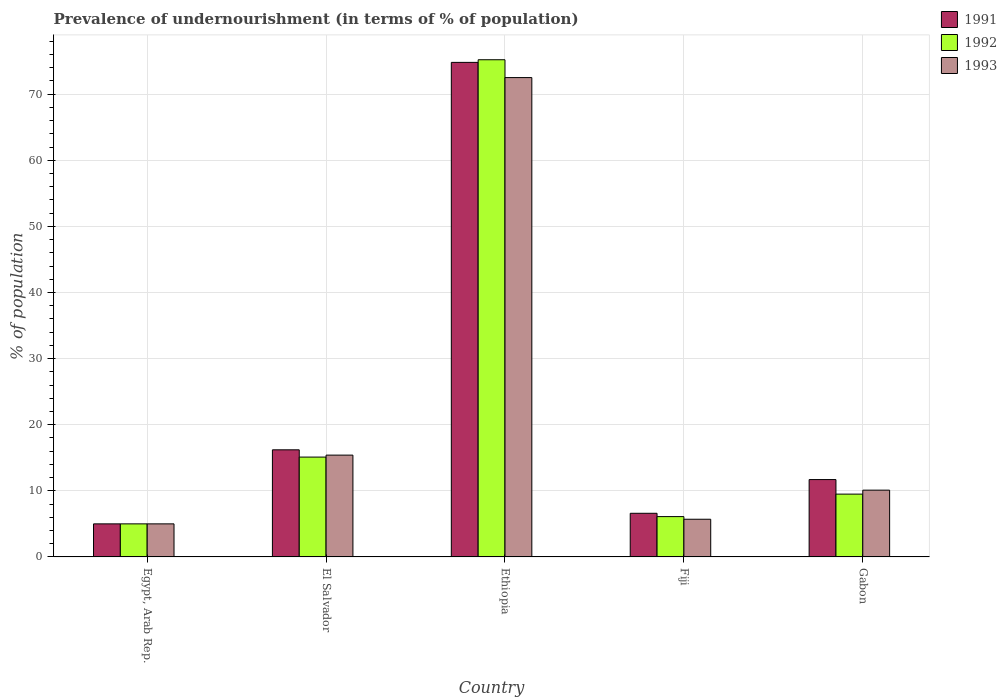How many different coloured bars are there?
Provide a short and direct response. 3. What is the label of the 1st group of bars from the left?
Keep it short and to the point. Egypt, Arab Rep. What is the percentage of undernourished population in 1993 in Ethiopia?
Offer a terse response. 72.5. Across all countries, what is the maximum percentage of undernourished population in 1993?
Provide a short and direct response. 72.5. In which country was the percentage of undernourished population in 1992 maximum?
Your answer should be compact. Ethiopia. In which country was the percentage of undernourished population in 1992 minimum?
Your answer should be very brief. Egypt, Arab Rep. What is the total percentage of undernourished population in 1991 in the graph?
Your response must be concise. 114.3. What is the difference between the percentage of undernourished population in 1993 in El Salvador and that in Ethiopia?
Give a very brief answer. -57.1. What is the average percentage of undernourished population in 1992 per country?
Offer a terse response. 22.18. What is the difference between the percentage of undernourished population of/in 1991 and percentage of undernourished population of/in 1993 in Fiji?
Provide a short and direct response. 0.9. In how many countries, is the percentage of undernourished population in 1992 greater than 46 %?
Make the answer very short. 1. What is the ratio of the percentage of undernourished population in 1991 in Fiji to that in Gabon?
Make the answer very short. 0.56. Is the percentage of undernourished population in 1991 in Fiji less than that in Gabon?
Offer a very short reply. Yes. Is the difference between the percentage of undernourished population in 1991 in Egypt, Arab Rep. and El Salvador greater than the difference between the percentage of undernourished population in 1993 in Egypt, Arab Rep. and El Salvador?
Provide a succinct answer. No. What is the difference between the highest and the second highest percentage of undernourished population in 1992?
Your answer should be compact. -65.7. What is the difference between the highest and the lowest percentage of undernourished population in 1992?
Your response must be concise. 70.2. What does the 1st bar from the left in Ethiopia represents?
Give a very brief answer. 1991. What does the 1st bar from the right in Fiji represents?
Offer a very short reply. 1993. Is it the case that in every country, the sum of the percentage of undernourished population in 1993 and percentage of undernourished population in 1992 is greater than the percentage of undernourished population in 1991?
Your answer should be very brief. Yes. How many countries are there in the graph?
Keep it short and to the point. 5. What is the difference between two consecutive major ticks on the Y-axis?
Make the answer very short. 10. Where does the legend appear in the graph?
Offer a terse response. Top right. How many legend labels are there?
Provide a succinct answer. 3. How are the legend labels stacked?
Your response must be concise. Vertical. What is the title of the graph?
Keep it short and to the point. Prevalence of undernourishment (in terms of % of population). Does "1961" appear as one of the legend labels in the graph?
Offer a terse response. No. What is the label or title of the Y-axis?
Offer a very short reply. % of population. What is the % of population in 1991 in Egypt, Arab Rep.?
Give a very brief answer. 5. What is the % of population in 1992 in Egypt, Arab Rep.?
Give a very brief answer. 5. What is the % of population of 1993 in Egypt, Arab Rep.?
Ensure brevity in your answer.  5. What is the % of population of 1992 in El Salvador?
Give a very brief answer. 15.1. What is the % of population of 1991 in Ethiopia?
Give a very brief answer. 74.8. What is the % of population of 1992 in Ethiopia?
Your response must be concise. 75.2. What is the % of population of 1993 in Ethiopia?
Your answer should be compact. 72.5. What is the % of population in 1992 in Fiji?
Provide a succinct answer. 6.1. What is the % of population of 1993 in Fiji?
Your answer should be compact. 5.7. What is the % of population of 1991 in Gabon?
Make the answer very short. 11.7. What is the % of population in 1992 in Gabon?
Ensure brevity in your answer.  9.5. Across all countries, what is the maximum % of population of 1991?
Your response must be concise. 74.8. Across all countries, what is the maximum % of population in 1992?
Provide a succinct answer. 75.2. Across all countries, what is the maximum % of population of 1993?
Keep it short and to the point. 72.5. Across all countries, what is the minimum % of population in 1991?
Your answer should be very brief. 5. Across all countries, what is the minimum % of population of 1992?
Provide a succinct answer. 5. What is the total % of population of 1991 in the graph?
Offer a terse response. 114.3. What is the total % of population of 1992 in the graph?
Provide a short and direct response. 110.9. What is the total % of population of 1993 in the graph?
Give a very brief answer. 108.7. What is the difference between the % of population in 1992 in Egypt, Arab Rep. and that in El Salvador?
Your answer should be very brief. -10.1. What is the difference between the % of population of 1991 in Egypt, Arab Rep. and that in Ethiopia?
Your answer should be compact. -69.8. What is the difference between the % of population in 1992 in Egypt, Arab Rep. and that in Ethiopia?
Offer a terse response. -70.2. What is the difference between the % of population of 1993 in Egypt, Arab Rep. and that in Ethiopia?
Offer a very short reply. -67.5. What is the difference between the % of population in 1993 in Egypt, Arab Rep. and that in Fiji?
Your answer should be very brief. -0.7. What is the difference between the % of population of 1993 in Egypt, Arab Rep. and that in Gabon?
Make the answer very short. -5.1. What is the difference between the % of population in 1991 in El Salvador and that in Ethiopia?
Ensure brevity in your answer.  -58.6. What is the difference between the % of population in 1992 in El Salvador and that in Ethiopia?
Provide a short and direct response. -60.1. What is the difference between the % of population in 1993 in El Salvador and that in Ethiopia?
Offer a terse response. -57.1. What is the difference between the % of population in 1991 in El Salvador and that in Fiji?
Ensure brevity in your answer.  9.6. What is the difference between the % of population in 1993 in El Salvador and that in Fiji?
Keep it short and to the point. 9.7. What is the difference between the % of population in 1992 in El Salvador and that in Gabon?
Your answer should be very brief. 5.6. What is the difference between the % of population of 1991 in Ethiopia and that in Fiji?
Provide a succinct answer. 68.2. What is the difference between the % of population in 1992 in Ethiopia and that in Fiji?
Provide a succinct answer. 69.1. What is the difference between the % of population in 1993 in Ethiopia and that in Fiji?
Ensure brevity in your answer.  66.8. What is the difference between the % of population in 1991 in Ethiopia and that in Gabon?
Provide a short and direct response. 63.1. What is the difference between the % of population in 1992 in Ethiopia and that in Gabon?
Your answer should be very brief. 65.7. What is the difference between the % of population of 1993 in Ethiopia and that in Gabon?
Provide a succinct answer. 62.4. What is the difference between the % of population of 1993 in Fiji and that in Gabon?
Provide a succinct answer. -4.4. What is the difference between the % of population of 1991 in Egypt, Arab Rep. and the % of population of 1992 in El Salvador?
Ensure brevity in your answer.  -10.1. What is the difference between the % of population in 1991 in Egypt, Arab Rep. and the % of population in 1992 in Ethiopia?
Provide a short and direct response. -70.2. What is the difference between the % of population in 1991 in Egypt, Arab Rep. and the % of population in 1993 in Ethiopia?
Keep it short and to the point. -67.5. What is the difference between the % of population in 1992 in Egypt, Arab Rep. and the % of population in 1993 in Ethiopia?
Offer a terse response. -67.5. What is the difference between the % of population in 1991 in Egypt, Arab Rep. and the % of population in 1993 in Fiji?
Offer a very short reply. -0.7. What is the difference between the % of population of 1992 in Egypt, Arab Rep. and the % of population of 1993 in Fiji?
Offer a terse response. -0.7. What is the difference between the % of population of 1991 in El Salvador and the % of population of 1992 in Ethiopia?
Provide a short and direct response. -59. What is the difference between the % of population of 1991 in El Salvador and the % of population of 1993 in Ethiopia?
Provide a succinct answer. -56.3. What is the difference between the % of population in 1992 in El Salvador and the % of population in 1993 in Ethiopia?
Your answer should be compact. -57.4. What is the difference between the % of population in 1991 in El Salvador and the % of population in 1992 in Fiji?
Ensure brevity in your answer.  10.1. What is the difference between the % of population of 1991 in El Salvador and the % of population of 1993 in Gabon?
Make the answer very short. 6.1. What is the difference between the % of population in 1991 in Ethiopia and the % of population in 1992 in Fiji?
Your answer should be compact. 68.7. What is the difference between the % of population of 1991 in Ethiopia and the % of population of 1993 in Fiji?
Ensure brevity in your answer.  69.1. What is the difference between the % of population of 1992 in Ethiopia and the % of population of 1993 in Fiji?
Make the answer very short. 69.5. What is the difference between the % of population of 1991 in Ethiopia and the % of population of 1992 in Gabon?
Your answer should be very brief. 65.3. What is the difference between the % of population of 1991 in Ethiopia and the % of population of 1993 in Gabon?
Your answer should be very brief. 64.7. What is the difference between the % of population of 1992 in Ethiopia and the % of population of 1993 in Gabon?
Offer a terse response. 65.1. What is the difference between the % of population of 1991 in Fiji and the % of population of 1993 in Gabon?
Your answer should be very brief. -3.5. What is the difference between the % of population in 1992 in Fiji and the % of population in 1993 in Gabon?
Provide a succinct answer. -4. What is the average % of population of 1991 per country?
Your answer should be compact. 22.86. What is the average % of population of 1992 per country?
Offer a very short reply. 22.18. What is the average % of population of 1993 per country?
Keep it short and to the point. 21.74. What is the difference between the % of population of 1991 and % of population of 1992 in Egypt, Arab Rep.?
Ensure brevity in your answer.  0. What is the difference between the % of population in 1992 and % of population in 1993 in Egypt, Arab Rep.?
Make the answer very short. 0. What is the difference between the % of population of 1991 and % of population of 1992 in El Salvador?
Provide a succinct answer. 1.1. What is the difference between the % of population in 1991 and % of population in 1993 in El Salvador?
Provide a short and direct response. 0.8. What is the difference between the % of population in 1991 and % of population in 1992 in Ethiopia?
Make the answer very short. -0.4. What is the difference between the % of population in 1991 and % of population in 1993 in Ethiopia?
Give a very brief answer. 2.3. What is the difference between the % of population of 1991 and % of population of 1993 in Fiji?
Offer a very short reply. 0.9. What is the difference between the % of population in 1991 and % of population in 1992 in Gabon?
Ensure brevity in your answer.  2.2. What is the difference between the % of population in 1991 and % of population in 1993 in Gabon?
Your response must be concise. 1.6. What is the difference between the % of population in 1992 and % of population in 1993 in Gabon?
Your answer should be compact. -0.6. What is the ratio of the % of population in 1991 in Egypt, Arab Rep. to that in El Salvador?
Make the answer very short. 0.31. What is the ratio of the % of population in 1992 in Egypt, Arab Rep. to that in El Salvador?
Give a very brief answer. 0.33. What is the ratio of the % of population of 1993 in Egypt, Arab Rep. to that in El Salvador?
Your answer should be very brief. 0.32. What is the ratio of the % of population in 1991 in Egypt, Arab Rep. to that in Ethiopia?
Ensure brevity in your answer.  0.07. What is the ratio of the % of population of 1992 in Egypt, Arab Rep. to that in Ethiopia?
Your response must be concise. 0.07. What is the ratio of the % of population in 1993 in Egypt, Arab Rep. to that in Ethiopia?
Give a very brief answer. 0.07. What is the ratio of the % of population in 1991 in Egypt, Arab Rep. to that in Fiji?
Ensure brevity in your answer.  0.76. What is the ratio of the % of population of 1992 in Egypt, Arab Rep. to that in Fiji?
Provide a short and direct response. 0.82. What is the ratio of the % of population in 1993 in Egypt, Arab Rep. to that in Fiji?
Give a very brief answer. 0.88. What is the ratio of the % of population in 1991 in Egypt, Arab Rep. to that in Gabon?
Offer a terse response. 0.43. What is the ratio of the % of population in 1992 in Egypt, Arab Rep. to that in Gabon?
Your answer should be very brief. 0.53. What is the ratio of the % of population in 1993 in Egypt, Arab Rep. to that in Gabon?
Provide a succinct answer. 0.49. What is the ratio of the % of population in 1991 in El Salvador to that in Ethiopia?
Your answer should be very brief. 0.22. What is the ratio of the % of population of 1992 in El Salvador to that in Ethiopia?
Your answer should be very brief. 0.2. What is the ratio of the % of population of 1993 in El Salvador to that in Ethiopia?
Provide a short and direct response. 0.21. What is the ratio of the % of population in 1991 in El Salvador to that in Fiji?
Your response must be concise. 2.45. What is the ratio of the % of population of 1992 in El Salvador to that in Fiji?
Offer a terse response. 2.48. What is the ratio of the % of population in 1993 in El Salvador to that in Fiji?
Your answer should be compact. 2.7. What is the ratio of the % of population in 1991 in El Salvador to that in Gabon?
Your response must be concise. 1.38. What is the ratio of the % of population of 1992 in El Salvador to that in Gabon?
Your answer should be compact. 1.59. What is the ratio of the % of population of 1993 in El Salvador to that in Gabon?
Offer a very short reply. 1.52. What is the ratio of the % of population in 1991 in Ethiopia to that in Fiji?
Keep it short and to the point. 11.33. What is the ratio of the % of population in 1992 in Ethiopia to that in Fiji?
Keep it short and to the point. 12.33. What is the ratio of the % of population of 1993 in Ethiopia to that in Fiji?
Your response must be concise. 12.72. What is the ratio of the % of population in 1991 in Ethiopia to that in Gabon?
Ensure brevity in your answer.  6.39. What is the ratio of the % of population of 1992 in Ethiopia to that in Gabon?
Make the answer very short. 7.92. What is the ratio of the % of population of 1993 in Ethiopia to that in Gabon?
Offer a very short reply. 7.18. What is the ratio of the % of population in 1991 in Fiji to that in Gabon?
Provide a succinct answer. 0.56. What is the ratio of the % of population in 1992 in Fiji to that in Gabon?
Keep it short and to the point. 0.64. What is the ratio of the % of population in 1993 in Fiji to that in Gabon?
Offer a terse response. 0.56. What is the difference between the highest and the second highest % of population in 1991?
Your response must be concise. 58.6. What is the difference between the highest and the second highest % of population in 1992?
Your response must be concise. 60.1. What is the difference between the highest and the second highest % of population in 1993?
Offer a terse response. 57.1. What is the difference between the highest and the lowest % of population of 1991?
Ensure brevity in your answer.  69.8. What is the difference between the highest and the lowest % of population of 1992?
Your answer should be very brief. 70.2. What is the difference between the highest and the lowest % of population of 1993?
Your response must be concise. 67.5. 